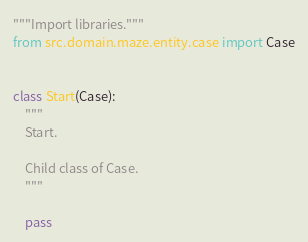<code> <loc_0><loc_0><loc_500><loc_500><_Python_>"""Import libraries."""
from src.domain.maze.entity.case import Case


class Start(Case):
    """
    Start.

    Child class of Case.
    """

    pass
</code> 